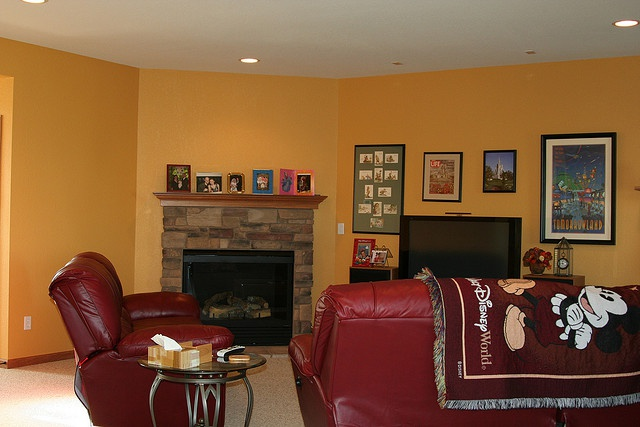Describe the objects in this image and their specific colors. I can see couch in tan, maroon, black, and brown tones, couch in tan, maroon, brown, and olive tones, chair in tan, maroon, black, and brown tones, tv in tan, black, olive, and maroon tones, and potted plant in tan, black, maroon, and olive tones in this image. 